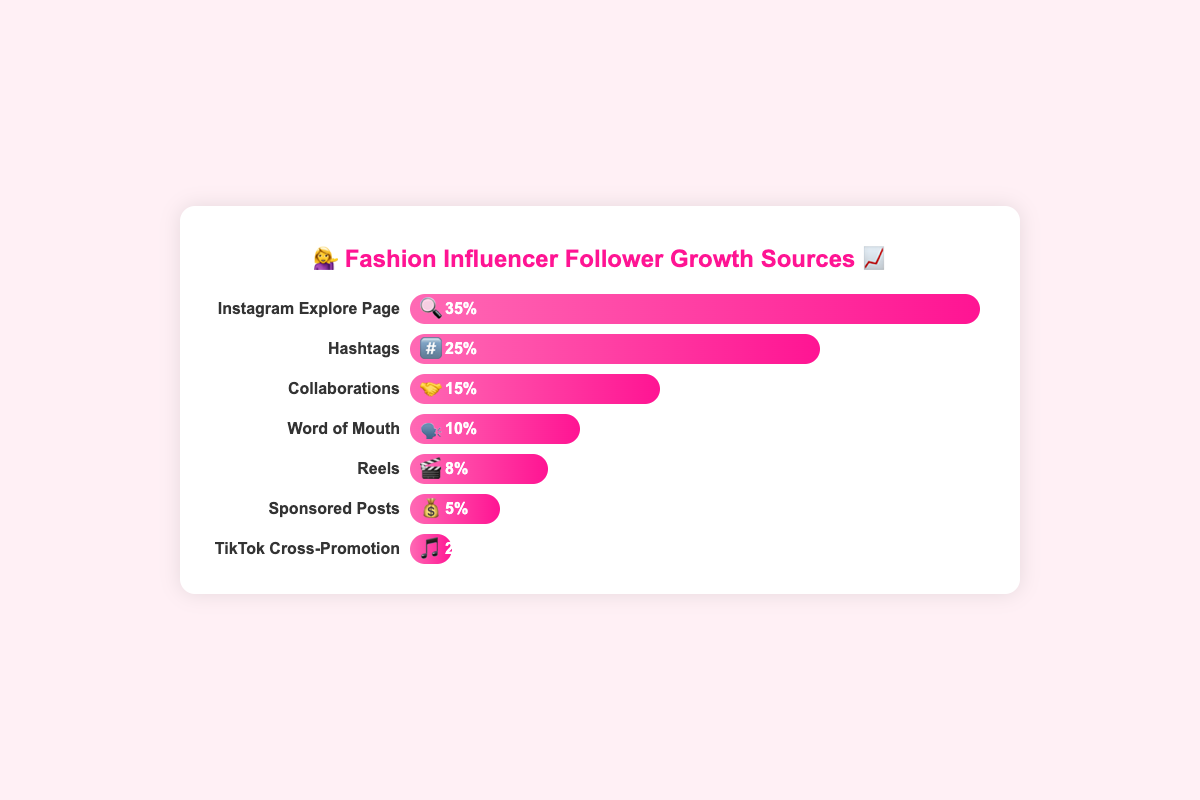What is the largest source of follower growth? The largest bar represents the biggest source of follower growth. "Instagram Explore Page" is the tallest bar, indicating it contributes the most with 35%.
Answer: Instagram Explore Page Which source contributes the least to follower growth? The shortest bar represents the smallest source of follower growth. "TikTok Cross-Promotion" is the shortest with only 2%.
Answer: TikTok Cross-Promotion What percentage of followers come from collaborations and Reels combined? Sum the percentages of "Collaborations" (15%) and "Reels" (8%). 15% + 8% equals 23%.
Answer: 23% Which is more effective for follower growth: hashtags or sponsored posts, and by how much? Compare the percentages of "Hashtags" (25%) and "Sponsored Posts" (5%). 25% - 5% equals a 20% difference.
Answer: Hashtags by 20% How many sources contribute less than 10% each to follower growth? Count the sources whose percentage is less than 10%. "Reels" (8%), "Sponsored Posts" (5%), and "TikTok Cross-Promotion" (2%) are three sources under 10%.
Answer: 3 What is the average percentage contribution of all sources to follower growth? Sum all percentages (35% + 25% + 15% + 10% + 8% + 5% + 2%) to get 100%, then divide by the number of sources (7). 100% / 7 equals approximately 14.29%.
Answer: 14.29% Which two sources combined have the highest follower growth? Add the percentages of each possible pair and find the maximum sum. "Instagram Explore Page" (35%) and "Hashtags" (25%) sum to 60%, the highest combined.
Answer: Instagram Explore Page and Hashtags By how much do Instagram Explore Page and Word of Mouth differ in their follower growth contributions? Subtract the percentage of "Word of Mouth" (10%) from "Instagram Explore Page" (35%). 35% - 10% equals a 25% difference.
Answer: 25% If the percentage contribution of Reels doubled, how would it compare to Collaborations? Double the Reels percentage (8% * 2 = 16%). Compare it to Collaborations (15%). 16% is greater than 15%.
Answer: Reels would be greater than Collaborations What is the total percentage contribution of social media-specific sources like Instagram Explore Page, Hashtags, and TikTok Cross-Promotion? Sum the percentages of these sources: Instagram Explore Page (35%), Hashtags (25%), and TikTok Cross-Promotion (2%). 35% + 25% + 2% equals 62%.
Answer: 62% 